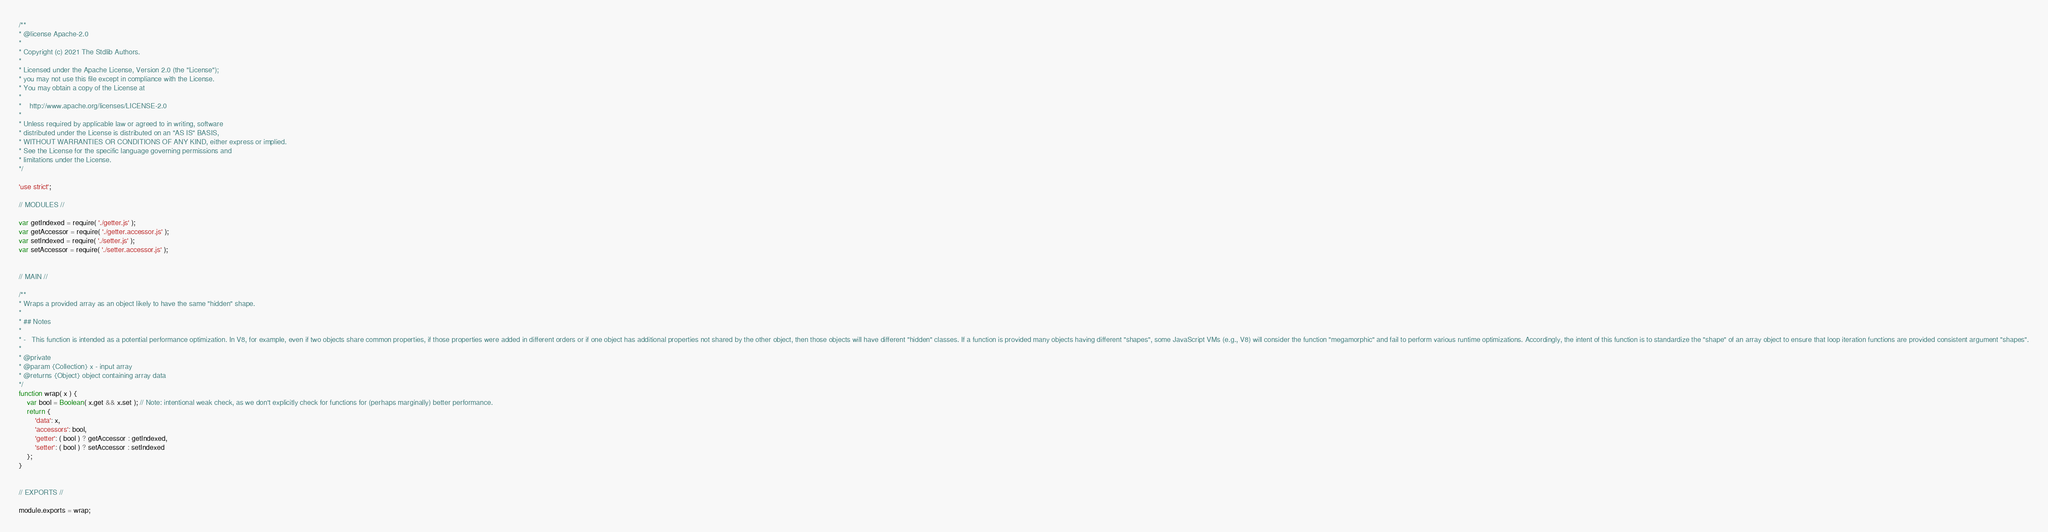<code> <loc_0><loc_0><loc_500><loc_500><_JavaScript_>/**
* @license Apache-2.0
*
* Copyright (c) 2021 The Stdlib Authors.
*
* Licensed under the Apache License, Version 2.0 (the "License");
* you may not use this file except in compliance with the License.
* You may obtain a copy of the License at
*
*    http://www.apache.org/licenses/LICENSE-2.0
*
* Unless required by applicable law or agreed to in writing, software
* distributed under the License is distributed on an "AS IS" BASIS,
* WITHOUT WARRANTIES OR CONDITIONS OF ANY KIND, either express or implied.
* See the License for the specific language governing permissions and
* limitations under the License.
*/

'use strict';

// MODULES //

var getIndexed = require( './getter.js' );
var getAccessor = require( './getter.accessor.js' );
var setIndexed = require( './setter.js' );
var setAccessor = require( './setter.accessor.js' );


// MAIN //

/**
* Wraps a provided array as an object likely to have the same "hidden" shape.
*
* ## Notes
*
* -   This function is intended as a potential performance optimization. In V8, for example, even if two objects share common properties, if those properties were added in different orders or if one object has additional properties not shared by the other object, then those objects will have different "hidden" classes. If a function is provided many objects having different "shapes", some JavaScript VMs (e.g., V8) will consider the function "megamorphic" and fail to perform various runtime optimizations. Accordingly, the intent of this function is to standardize the "shape" of an array object to ensure that loop iteration functions are provided consistent argument "shapes".
*
* @private
* @param {Collection} x - input array
* @returns {Object} object containing array data
*/
function wrap( x ) {
	var bool = Boolean( x.get && x.set ); // Note: intentional weak check, as we don't explicitly check for functions for (perhaps marginally) better performance.
	return {
		'data': x,
		'accessors': bool,
		'getter': ( bool ) ? getAccessor : getIndexed,
		'setter': ( bool ) ? setAccessor : setIndexed
	};
}


// EXPORTS //

module.exports = wrap;
</code> 